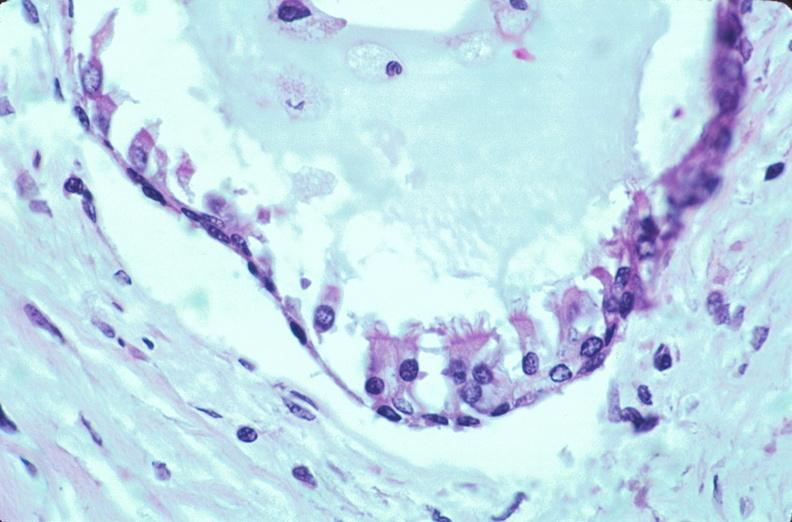what is present?
Answer the question using a single word or phrase. Embryo-fetus 